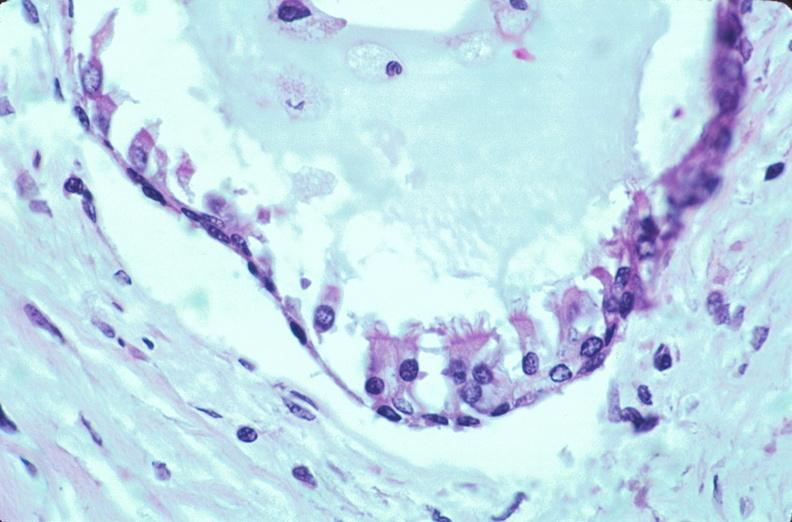what is present?
Answer the question using a single word or phrase. Embryo-fetus 